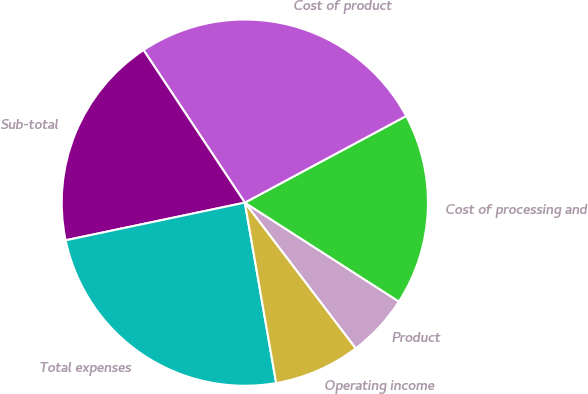Convert chart to OTSL. <chart><loc_0><loc_0><loc_500><loc_500><pie_chart><fcel>Product<fcel>Cost of processing and<fcel>Cost of product<fcel>Sub-total<fcel>Total expenses<fcel>Operating income<nl><fcel>5.57%<fcel>16.93%<fcel>26.49%<fcel>18.97%<fcel>24.44%<fcel>7.61%<nl></chart> 